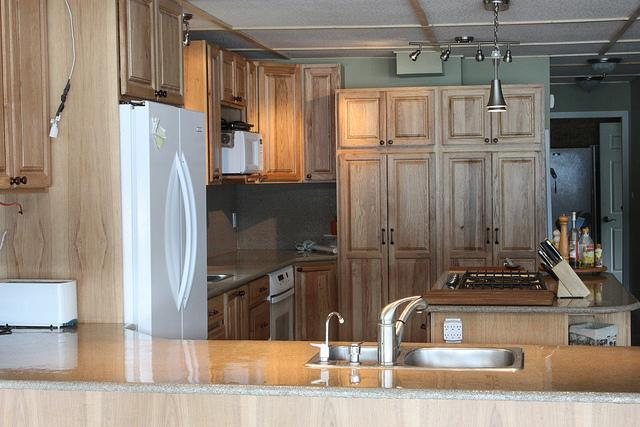Why are there wires sticking out of the wall?

Choices:
A) inspection
B) decoration
C) demolition
D) new construction new construction 